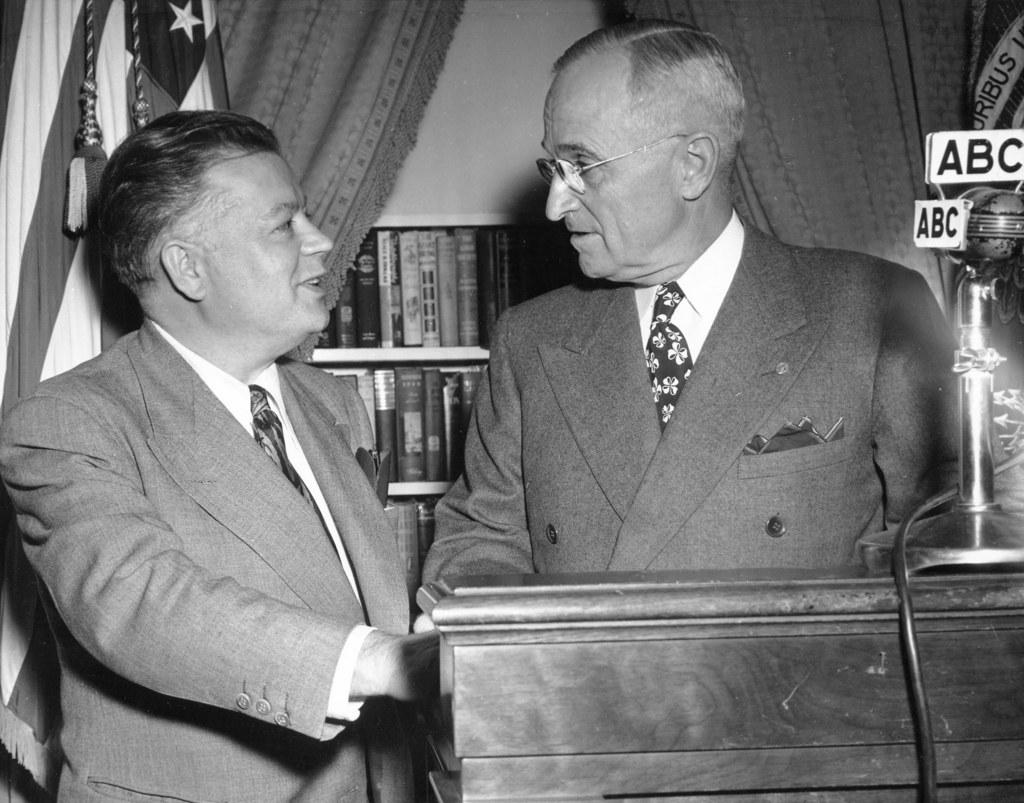<image>
Summarize the visual content of the image. Two men in a suit are standing in front of a flag and close to some microphone with ABC signs. 